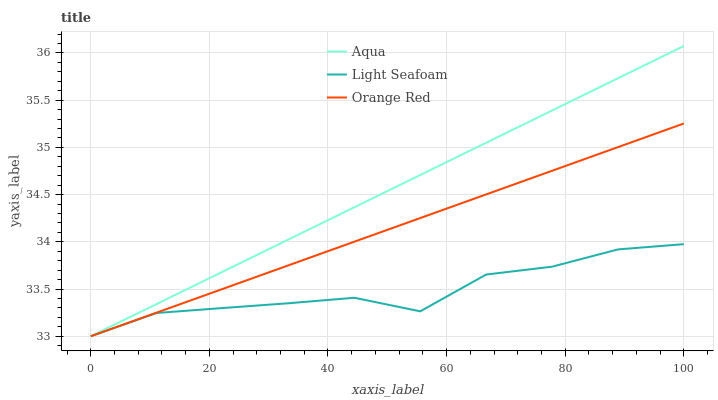Does Orange Red have the minimum area under the curve?
Answer yes or no. No. Does Orange Red have the maximum area under the curve?
Answer yes or no. No. Is Aqua the smoothest?
Answer yes or no. No. Is Aqua the roughest?
Answer yes or no. No. Does Orange Red have the highest value?
Answer yes or no. No. 